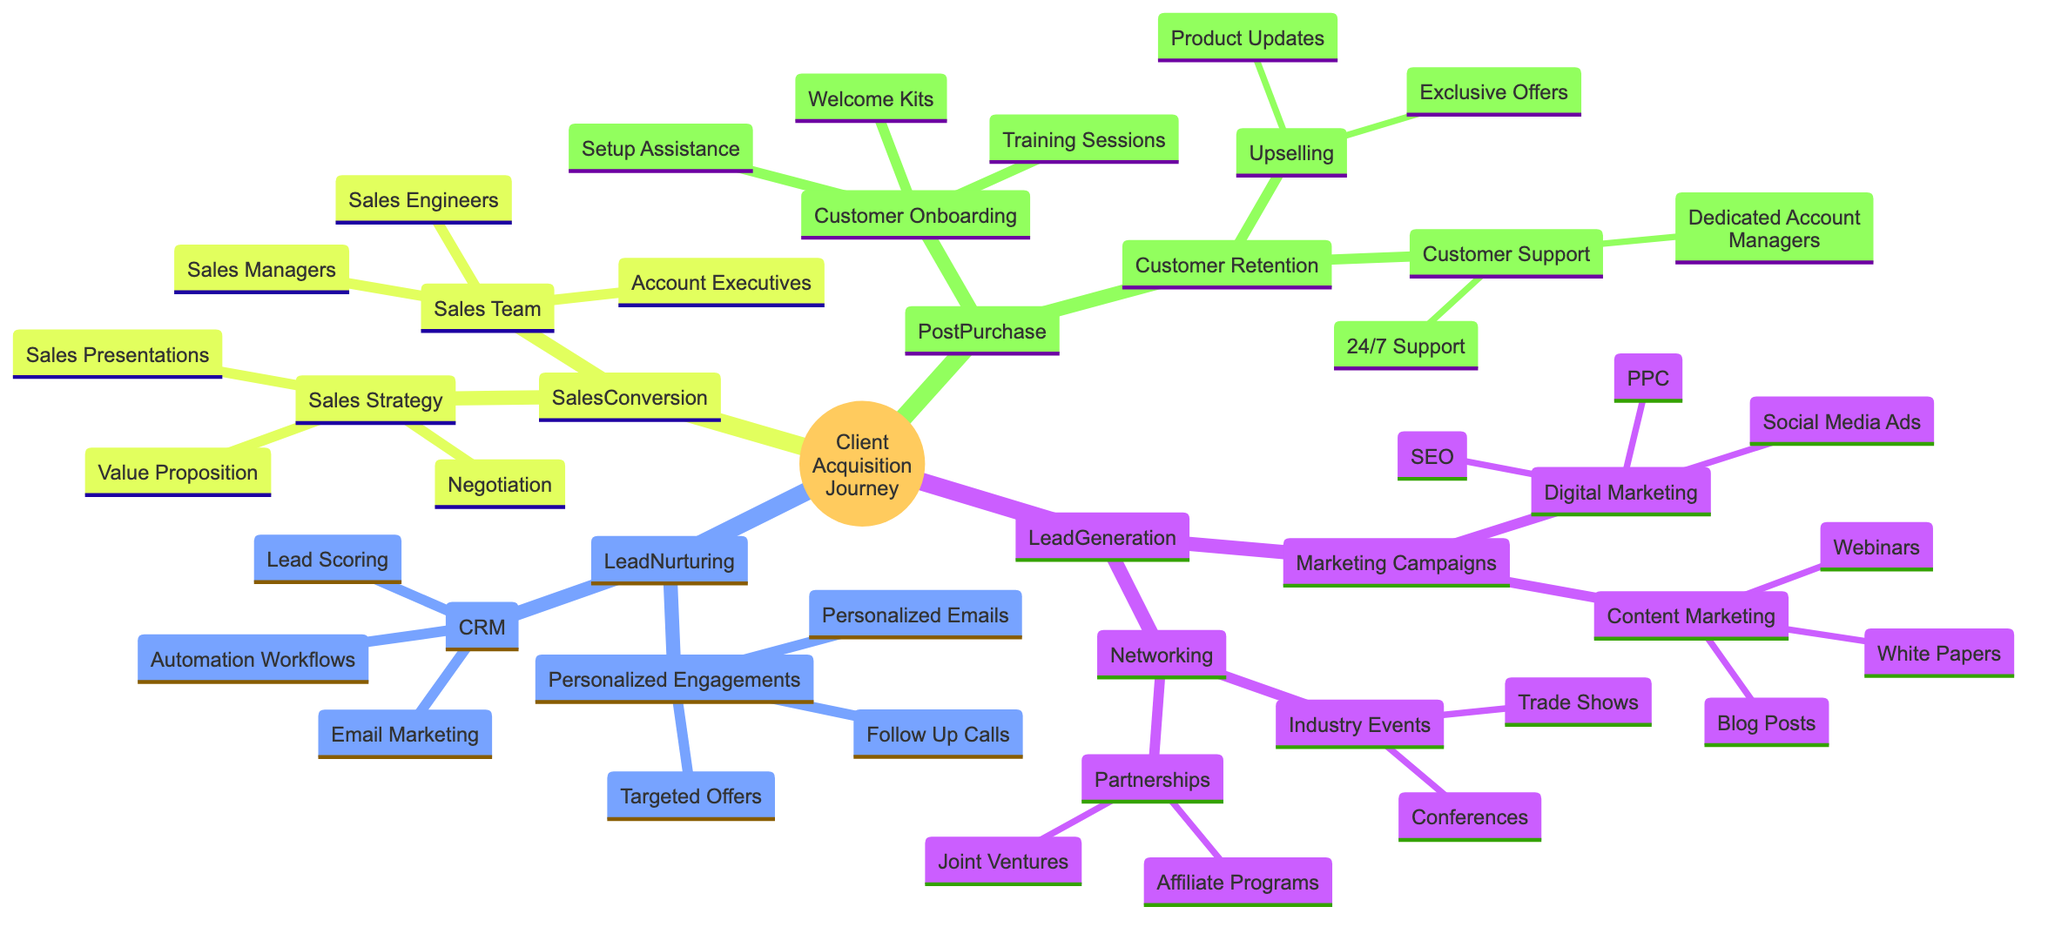What is the first stage in the Client Acquisition Journey? The diagram indicates that the first stage is "Lead Generation." This is shown at the top level of the family tree.
Answer: Lead Generation How many types of marketing campaigns are listed? In the "Marketing Campaigns" section, there are two types listed: "Digital Marketing" and "Content Marketing." This is found under the "Lead Generation" node.
Answer: 2 What engagement tactics are included in Lead Nurturing? Under "Lead Nurturing," there are two main tactics: "CRM" and "Personalized Engagements." These categories contain specific tactics like Email Marketing and Personalized Emails.
Answer: CRM, Personalized Engagements Which components are part of Customer Retention? The "Customer Retention" node includes "Customer Support" and "Upselling." Each of these components further breaks down into specific actions, such as 24/7 Support.
Answer: Customer Support, Upselling How many different roles are part of the Sales Team? The "Sales Team" node lists three roles: "Account Executives," "Sales Engineers," and "Sales Managers." This is a direct count of the items under that node.
Answer: 3 What are the elements of Digital Marketing? Under the "Digital Marketing" section within "Marketing Campaigns," three elements are listed: "SEO," "PPC," and "Social Media Ads." This is noted under the respective node.
Answer: SEO, PPC, Social Media Ads How does Lead Nurturing connect to Sales Conversion? Lead Nurturing flows into the Sales Conversion stage. This signifies that after nurturing leads, the next step involves strategies for converting those leads into sales, reflecting a direct progression in the journey.
Answer: Sales Conversion What is the strategy used during Sales Conversion? The "Sales Strategy" within Sales Conversion lists three tactics: "Value Proposition," "Sales Presentations," and "Negotiation." These strategies are crucial for converting leads into customers.
Answer: Value Proposition, Sales Presentations, Negotiation What does the Customer Onboarding process include? The "Customer Onboarding" section includes three components: "Training Sessions," "Setup Assistance," and "Welcome Kits." Each component represents a method to help new customers get started.
Answer: Training Sessions, Setup Assistance, Welcome Kits 